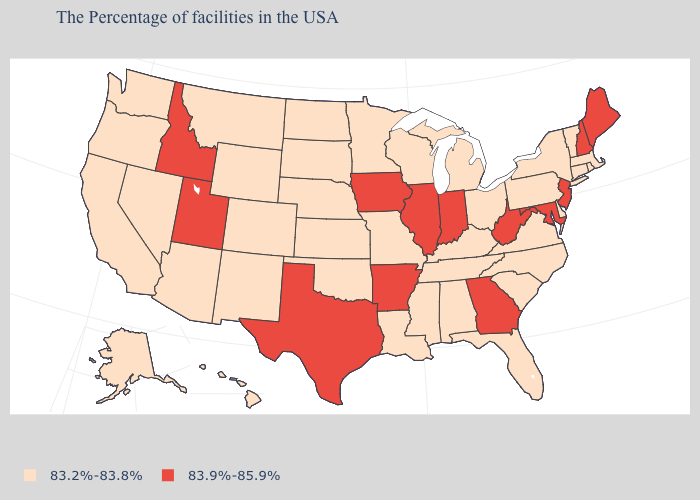Name the states that have a value in the range 83.9%-85.9%?
Keep it brief. Maine, New Hampshire, New Jersey, Maryland, West Virginia, Georgia, Indiana, Illinois, Arkansas, Iowa, Texas, Utah, Idaho. Name the states that have a value in the range 83.2%-83.8%?
Write a very short answer. Massachusetts, Rhode Island, Vermont, Connecticut, New York, Delaware, Pennsylvania, Virginia, North Carolina, South Carolina, Ohio, Florida, Michigan, Kentucky, Alabama, Tennessee, Wisconsin, Mississippi, Louisiana, Missouri, Minnesota, Kansas, Nebraska, Oklahoma, South Dakota, North Dakota, Wyoming, Colorado, New Mexico, Montana, Arizona, Nevada, California, Washington, Oregon, Alaska, Hawaii. How many symbols are there in the legend?
Quick response, please. 2. Name the states that have a value in the range 83.2%-83.8%?
Write a very short answer. Massachusetts, Rhode Island, Vermont, Connecticut, New York, Delaware, Pennsylvania, Virginia, North Carolina, South Carolina, Ohio, Florida, Michigan, Kentucky, Alabama, Tennessee, Wisconsin, Mississippi, Louisiana, Missouri, Minnesota, Kansas, Nebraska, Oklahoma, South Dakota, North Dakota, Wyoming, Colorado, New Mexico, Montana, Arizona, Nevada, California, Washington, Oregon, Alaska, Hawaii. Name the states that have a value in the range 83.9%-85.9%?
Concise answer only. Maine, New Hampshire, New Jersey, Maryland, West Virginia, Georgia, Indiana, Illinois, Arkansas, Iowa, Texas, Utah, Idaho. Name the states that have a value in the range 83.9%-85.9%?
Write a very short answer. Maine, New Hampshire, New Jersey, Maryland, West Virginia, Georgia, Indiana, Illinois, Arkansas, Iowa, Texas, Utah, Idaho. What is the lowest value in the South?
Short answer required. 83.2%-83.8%. What is the value of Colorado?
Answer briefly. 83.2%-83.8%. What is the value of Delaware?
Be succinct. 83.2%-83.8%. What is the value of Florida?
Be succinct. 83.2%-83.8%. What is the value of Connecticut?
Write a very short answer. 83.2%-83.8%. Does Utah have the lowest value in the West?
Give a very brief answer. No. Which states have the lowest value in the MidWest?
Be succinct. Ohio, Michigan, Wisconsin, Missouri, Minnesota, Kansas, Nebraska, South Dakota, North Dakota. What is the value of West Virginia?
Concise answer only. 83.9%-85.9%. What is the value of Oregon?
Be succinct. 83.2%-83.8%. 